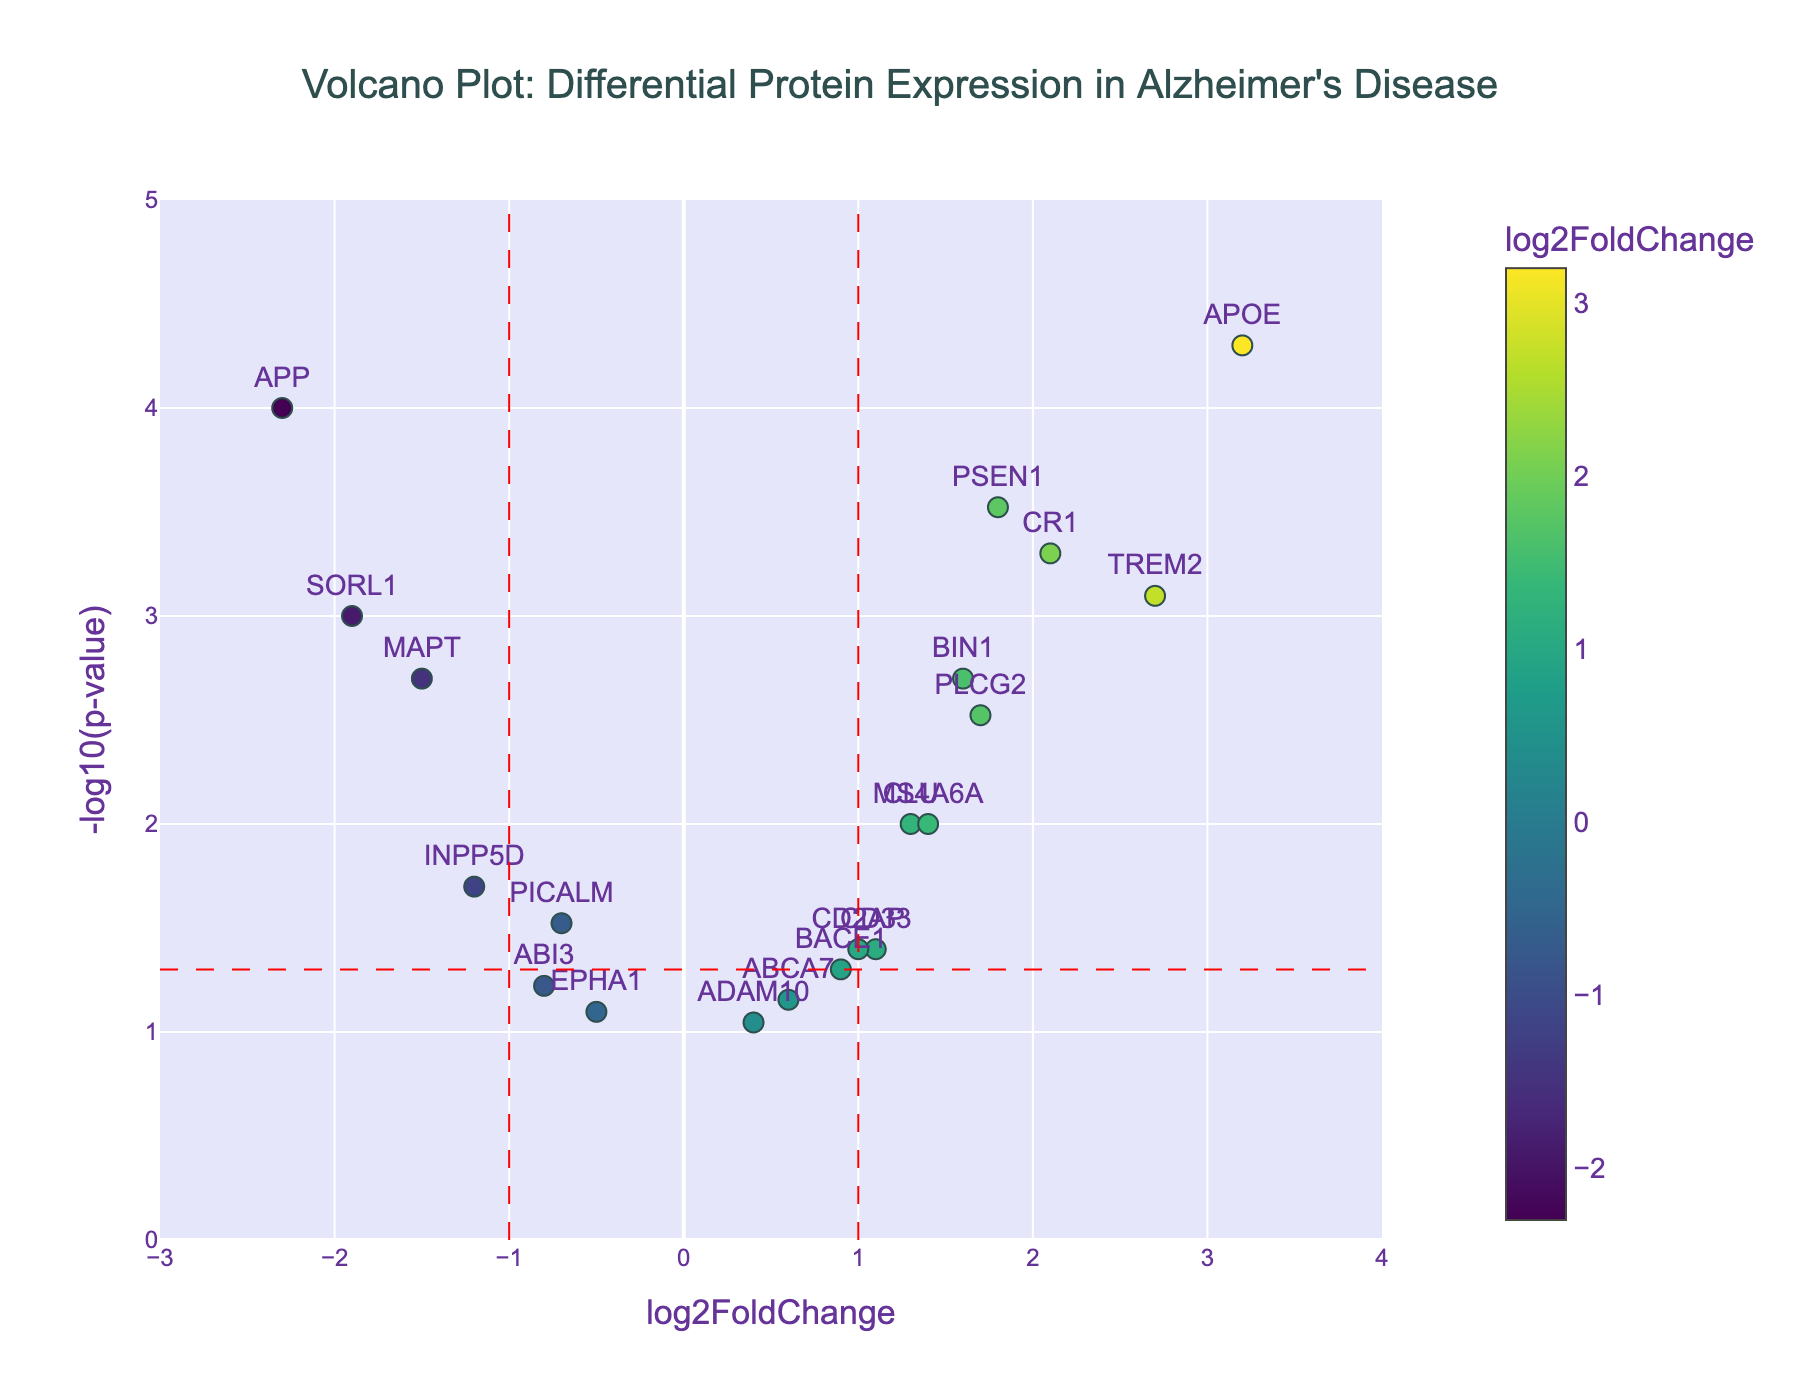what is the title of the plot? The title is centrally placed at the top of the plot. It reads "Volcano Plot: Differential Protein Expression in Alzheimer's Disease."
Answer: Volcano Plot: Differential Protein Expression in Alzheimer's Disease How many proteins have a log2FoldChange greater than 1? We need to count the markers positioned to the right of the vertical line at log2FoldChange = 1. There are 7 such proteins: PSEN1, TREM2, CLU, CD33, BIN1, CR1, and PLCG2.
Answer: 7 Which protein has the highest -log10(p-value)? By examining the y-axis, APOE reaches the highest point on the plot, indicating the highest -log10(p-value).
Answer: APOE What is the p-value threshold indicated by the horizontal red dashed line? The horizontal red dashed line represents the significance threshold for p-values. The y-axis shows -log10(0.05) which translates to a p-value of 0.05.
Answer: 0.05 Identify a protein with both log2FoldChange less than -1 and significant p-value (p < 0.05)? For significant p-values, markers must be above the horizontal red line. INPP5D and SORL1 both lie above this line and have log2FoldChange less than -1.
Answer: INPP5D or SORL1 How does the color coding work for the markers? The color scale represents log2FoldChange values. Lower log2FoldChange values are represented by colors on the colder end (purple), while higher values are on the warmer end (yellow-green).
Answer: Color represents log2FoldChange values Compare the log2FoldChange values between APP and TREM2. APP has a log2FoldChange of -2.3, while TREM2 has a log2FoldChange of 2.7. TREM2's value is higher (less negative/more positive) than APP's.
Answer: TREM2 has a higher log2FoldChange On average, how far from zero is the log2FoldChange for proteins with significant p-values? Calculate the average absolute log2FoldChange for proteins above the horizontal red line. Significant ones are APP (-2.3), PSEN1 (1.8), APOE (3.2), MAPT (-1.5), TREM2 (2.7), SORL1 (-1.9), BIN1 (1.6), CR1 (2.1), PLCG2 (1.7). Their absolute values average to (2.3 + 1.8 + 3.2 + 1.5 + 2.7 + 1.9 + 1.6 + 2.1 + 1.7) / 9 = 2.1.
Answer: 2.1 How many proteins are not statistically significant p > 0.05? Identify proteins positioned below the horizontal red line: BACE1, ABCA7, ADAM10, ABI3, EPHA1. There are 5 such proteins.
Answer: 5 